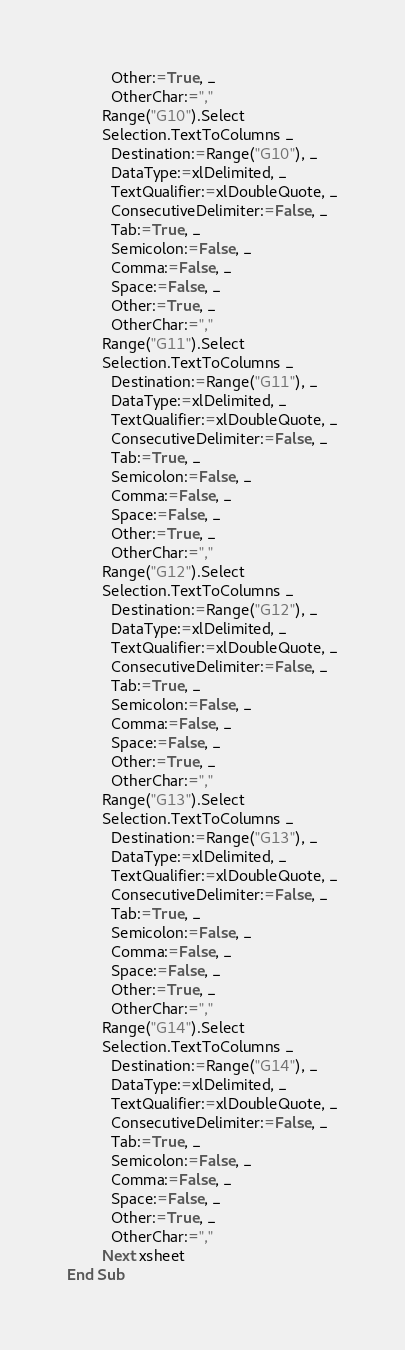<code> <loc_0><loc_0><loc_500><loc_500><_VisualBasic_>          Other:=True, _
          OtherChar:=","
        Range("G10").Select
        Selection.TextToColumns _
          Destination:=Range("G10"), _
          DataType:=xlDelimited, _
          TextQualifier:=xlDoubleQuote, _
          ConsecutiveDelimiter:=False, _
          Tab:=True, _
          Semicolon:=False, _
          Comma:=False, _
          Space:=False, _
          Other:=True, _
          OtherChar:=","
        Range("G11").Select
        Selection.TextToColumns _
          Destination:=Range("G11"), _
          DataType:=xlDelimited, _
          TextQualifier:=xlDoubleQuote, _
          ConsecutiveDelimiter:=False, _
          Tab:=True, _
          Semicolon:=False, _
          Comma:=False, _
          Space:=False, _
          Other:=True, _
          OtherChar:=","
        Range("G12").Select
        Selection.TextToColumns _
          Destination:=Range("G12"), _
          DataType:=xlDelimited, _
          TextQualifier:=xlDoubleQuote, _
          ConsecutiveDelimiter:=False, _
          Tab:=True, _
          Semicolon:=False, _
          Comma:=False, _
          Space:=False, _
          Other:=True, _
          OtherChar:=","
        Range("G13").Select
        Selection.TextToColumns _
          Destination:=Range("G13"), _
          DataType:=xlDelimited, _
          TextQualifier:=xlDoubleQuote, _
          ConsecutiveDelimiter:=False, _
          Tab:=True, _
          Semicolon:=False, _
          Comma:=False, _
          Space:=False, _
          Other:=True, _
          OtherChar:=","
        Range("G14").Select
        Selection.TextToColumns _
          Destination:=Range("G14"), _
          DataType:=xlDelimited, _
          TextQualifier:=xlDoubleQuote, _
          ConsecutiveDelimiter:=False, _
          Tab:=True, _
          Semicolon:=False, _
          Comma:=False, _
          Space:=False, _
          Other:=True, _
          OtherChar:=","
        Next xsheet
End Sub
</code> 